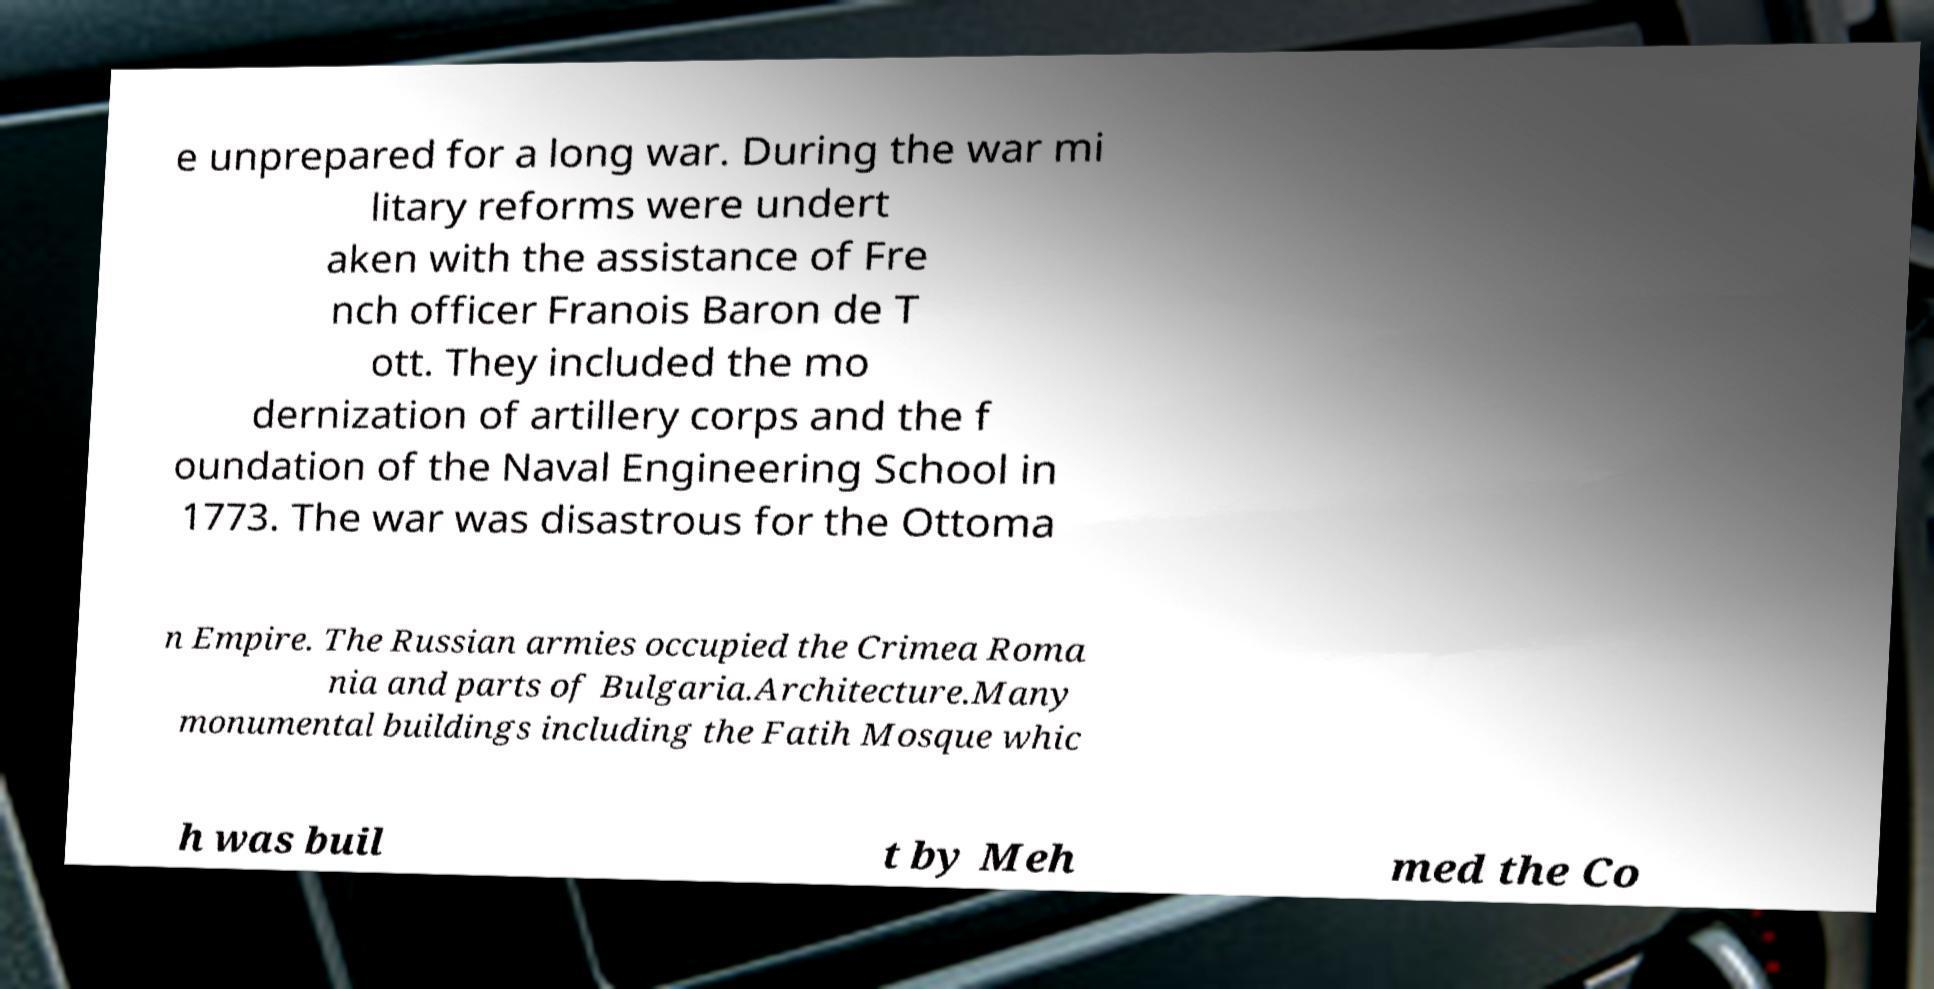Can you accurately transcribe the text from the provided image for me? e unprepared for a long war. During the war mi litary reforms were undert aken with the assistance of Fre nch officer Franois Baron de T ott. They included the mo dernization of artillery corps and the f oundation of the Naval Engineering School in 1773. The war was disastrous for the Ottoma n Empire. The Russian armies occupied the Crimea Roma nia and parts of Bulgaria.Architecture.Many monumental buildings including the Fatih Mosque whic h was buil t by Meh med the Co 